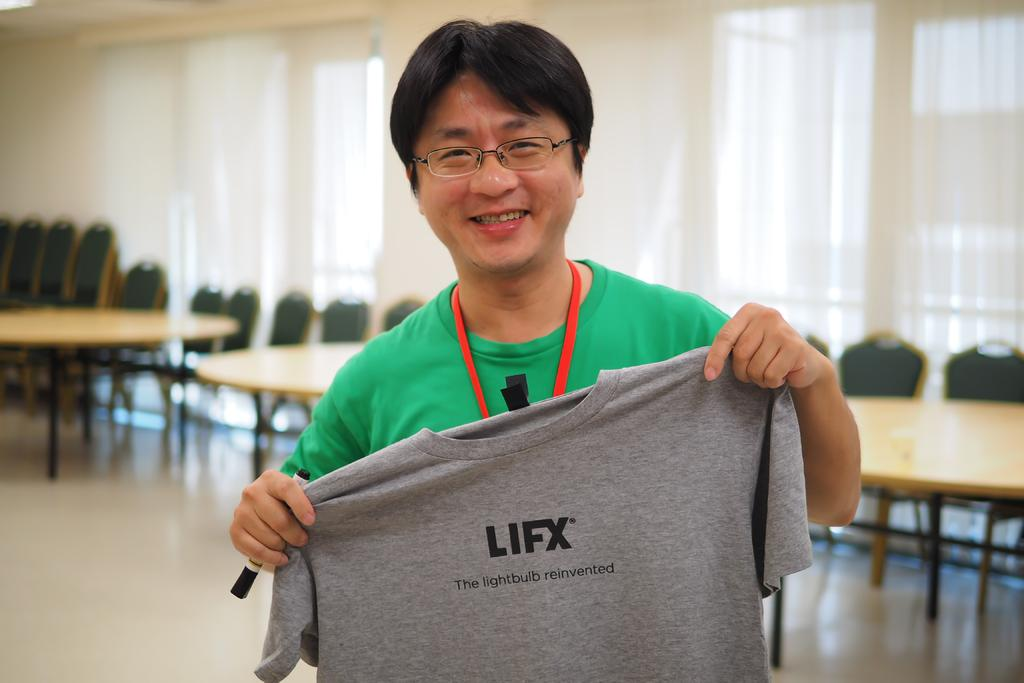Who is the main subject in the picture? There is a man highlighted in the picture. What is the man holding in the image? The man is holding an ash-colored t-shirt. Can you describe the man's appearance? The man is wearing spectacles. What type of furniture can be seen in the image? Chairs and tables are visible in the image. What is the color of the curtain in the image? There is a white curtain in the image. What type of throne is the man sitting on in the image? There is no throne present in the image; the man is standing and holding an ash-colored t-shirt. Can you tell me how many horses are visible in the image? There are no horses present in the image. 